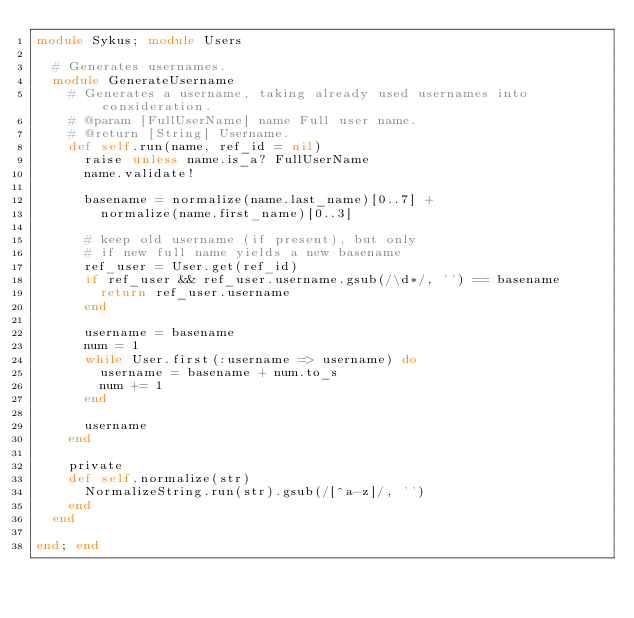<code> <loc_0><loc_0><loc_500><loc_500><_Ruby_>module Sykus; module Users

  # Generates usernames.
  module GenerateUsername
    # Generates a username, taking already used usernames into consideration.
    # @param [FullUserName] name Full user name.
    # @return [String] Username.
    def self.run(name, ref_id = nil)
      raise unless name.is_a? FullUserName
      name.validate!

      basename = normalize(name.last_name)[0..7] + 
        normalize(name.first_name)[0..3]

      # keep old username (if present), but only
      # if new full name yields a new basename
      ref_user = User.get(ref_id)
      if ref_user && ref_user.username.gsub(/\d*/, '') == basename
        return ref_user.username
      end

      username = basename
      num = 1
      while User.first(:username => username) do
        username = basename + num.to_s
        num += 1
      end

      username
    end

    private 
    def self.normalize(str)
      NormalizeString.run(str).gsub(/[^a-z]/, '')
    end
  end

end; end

</code> 